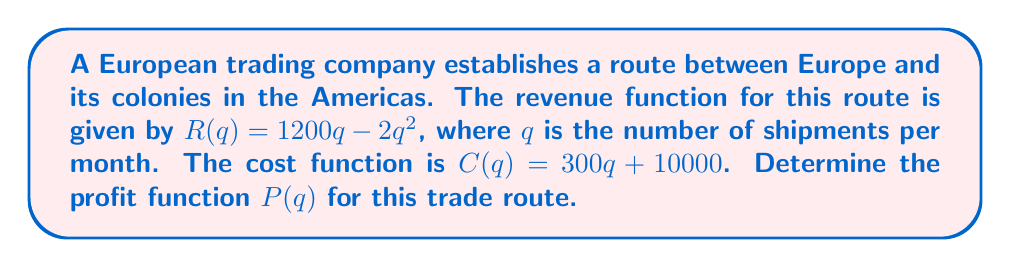Can you answer this question? To determine the profit function, we need to follow these steps:

1. Recall that profit is the difference between revenue and cost:
   $P(q) = R(q) - C(q)$

2. We are given the revenue function:
   $R(q) = 1200q - 2q^2$

3. We are also given the cost function:
   $C(q) = 300q + 10000$

4. Now, let's substitute these into the profit equation:
   $P(q) = (1200q - 2q^2) - (300q + 10000)$

5. Simplify by combining like terms:
   $P(q) = 1200q - 2q^2 - 300q - 10000$
   $P(q) = 900q - 2q^2 - 10000$

6. Rearrange the terms in standard form (descending powers of q):
   $P(q) = -2q^2 + 900q - 10000$

This is the profit function for the trade route between Europe and its colonies.
Answer: $P(q) = -2q^2 + 900q - 10000$ 